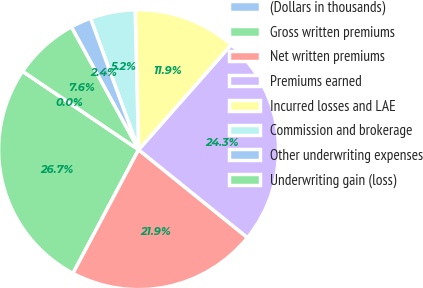<chart> <loc_0><loc_0><loc_500><loc_500><pie_chart><fcel>(Dollars in thousands)<fcel>Gross written premiums<fcel>Net written premiums<fcel>Premiums earned<fcel>Incurred losses and LAE<fcel>Commission and brokerage<fcel>Other underwriting expenses<fcel>Underwriting gain (loss)<nl><fcel>0.02%<fcel>26.68%<fcel>21.95%<fcel>24.31%<fcel>11.9%<fcel>5.19%<fcel>2.39%<fcel>7.56%<nl></chart> 